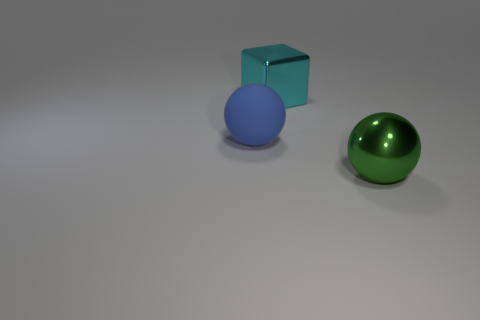Imagine these objects are part of a game. What could be the rules involving these three items? If the objects were part of a game, we could envisage a turn-based strategy game where each object represents a different game piece with unique moves and abilities. The green metallic ball could be a 'power piece' that can move in any direction but only on the outer edges of the gameboard. The blue cube could be a 'blocker piece' that can spawn temporary walls to redirect opponents. The blue ball might be a 'bouncer piece,' able to leap over other pieces with a ricochet effect. Players could aim to maneuver these pieces across the board to reach a fixed destination or to capture the other player's pieces. 